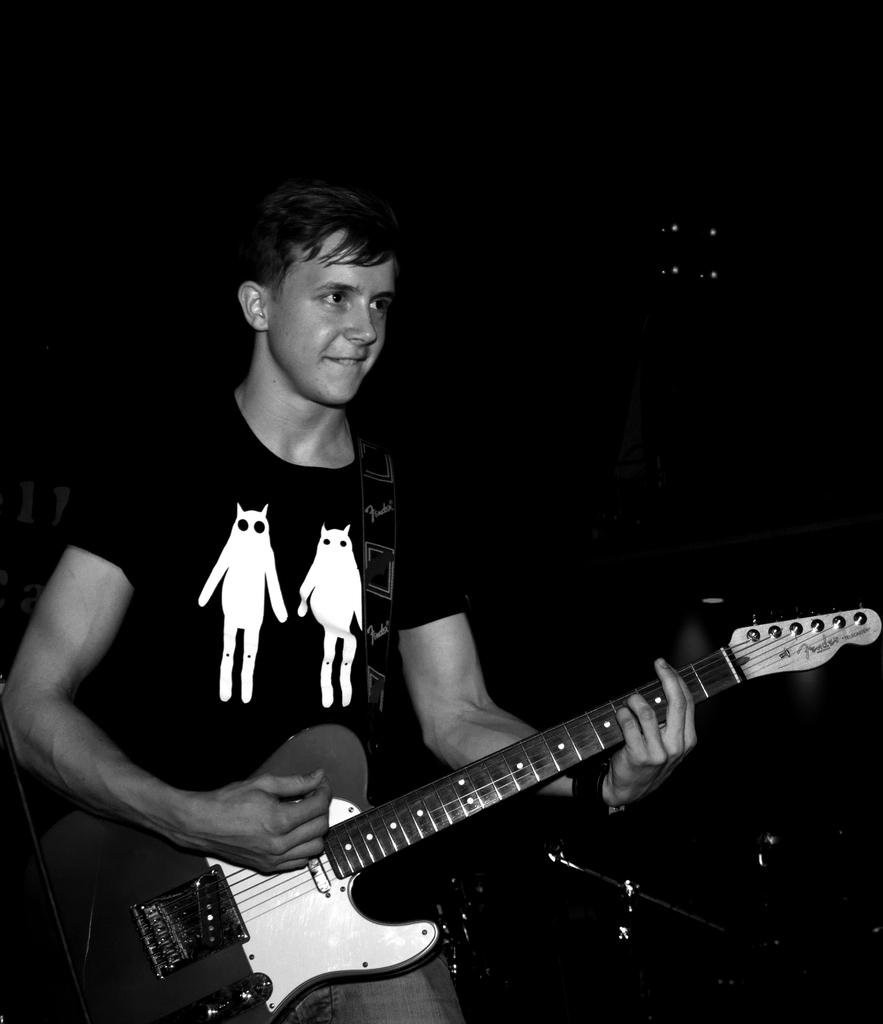What is the color scheme of the image? The image is black and white. What is the man in the image doing? The man is playing a guitar. How would you describe the background of the image? The background of the image is dark. What type of oatmeal is being served on the ship in the image? There is no oatmeal or ship present in the image; it features a man playing a guitar against a dark background. What shape is the guitar in the image? The shape of the guitar cannot be determined from the image, as it is in black and white and lacks detail. 